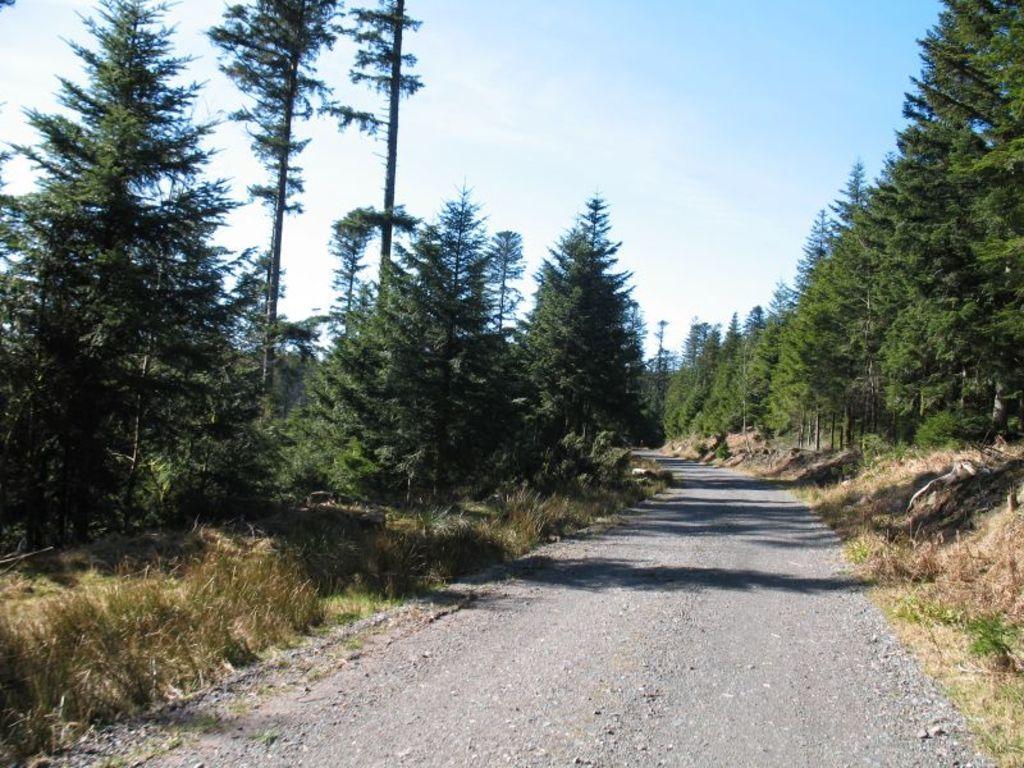Describe this image in one or two sentences. In this image we can see road, trees, grass and sky. 